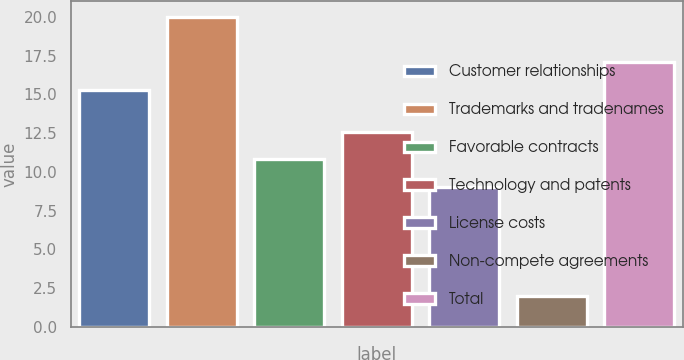Convert chart. <chart><loc_0><loc_0><loc_500><loc_500><bar_chart><fcel>Customer relationships<fcel>Trademarks and tradenames<fcel>Favorable contracts<fcel>Technology and patents<fcel>License costs<fcel>Non-compete agreements<fcel>Total<nl><fcel>15.3<fcel>20<fcel>10.8<fcel>12.6<fcel>9<fcel>2<fcel>17.1<nl></chart> 